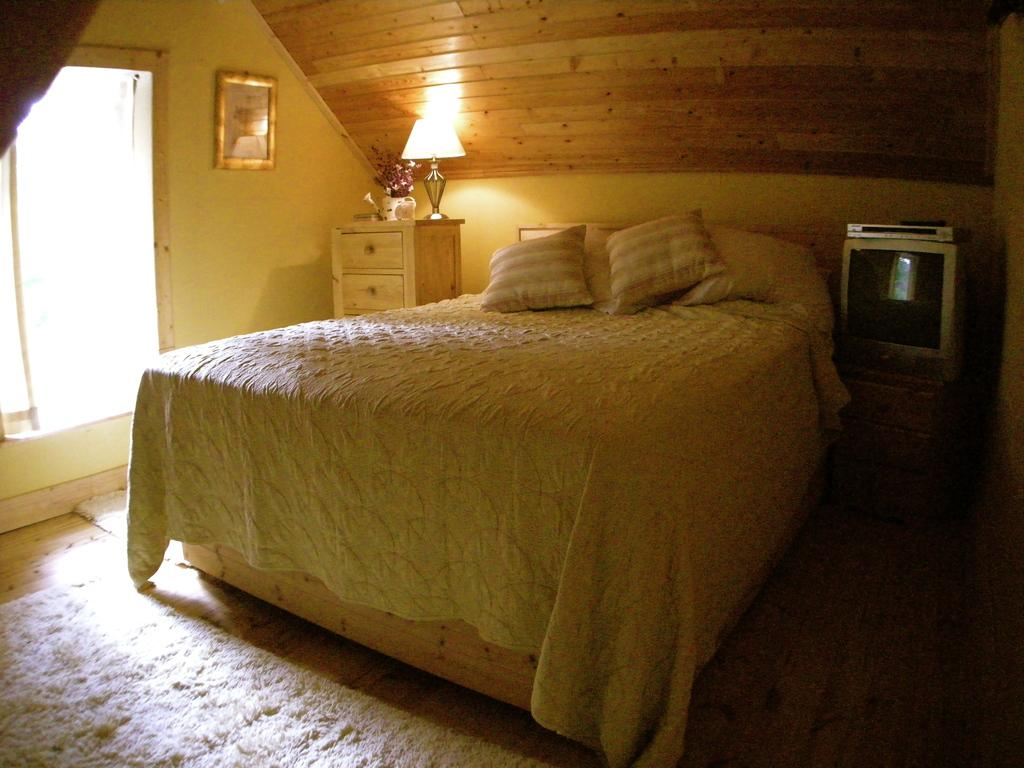What type of room is depicted in the image? The image is of a bedroom. Where is the scarecrow located in the bedroom? There is no scarecrow present in the bedroom; the image only shows a bedroom. What is the angle of the slope in the bedroom? There is no slope present in the bedroom; it is a typical room with a flat floor. 